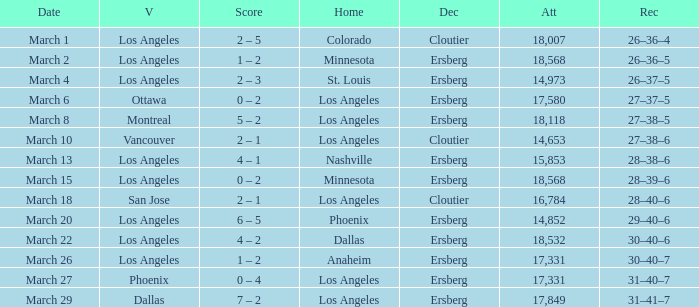On the Date of March 13, who was the Home team? Nashville. 